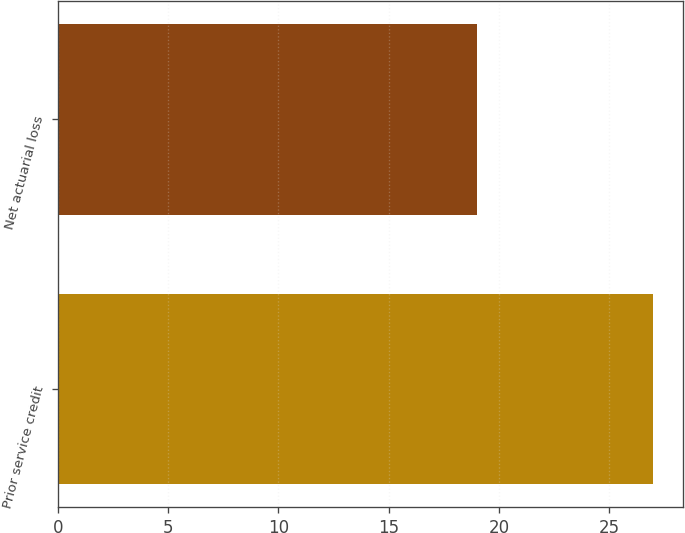Convert chart. <chart><loc_0><loc_0><loc_500><loc_500><bar_chart><fcel>Prior service credit<fcel>Net actuarial loss<nl><fcel>27<fcel>19<nl></chart> 